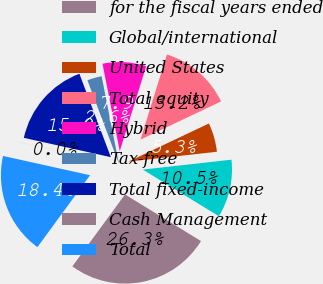Convert chart to OTSL. <chart><loc_0><loc_0><loc_500><loc_500><pie_chart><fcel>for the fiscal years ended<fcel>Global/international<fcel>United States<fcel>Total equity<fcel>Hybrid<fcel>Tax-free<fcel>Total fixed-income<fcel>Cash Management<fcel>Total<nl><fcel>26.3%<fcel>10.53%<fcel>5.27%<fcel>13.16%<fcel>7.9%<fcel>2.64%<fcel>15.78%<fcel>0.01%<fcel>18.41%<nl></chart> 